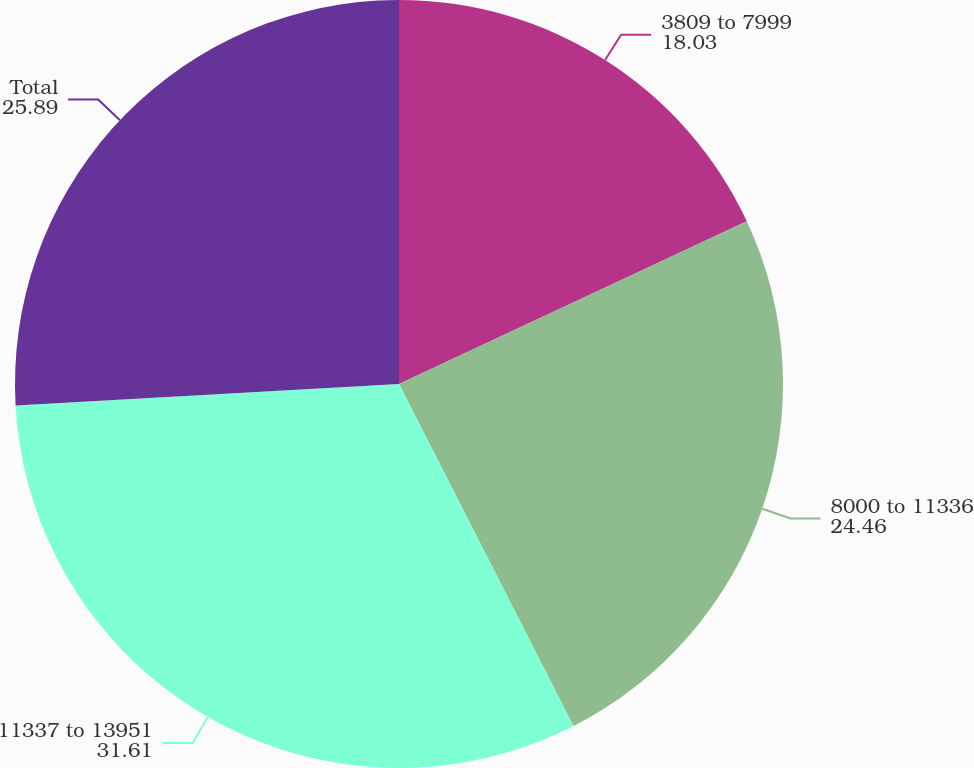Convert chart. <chart><loc_0><loc_0><loc_500><loc_500><pie_chart><fcel>3809 to 7999<fcel>8000 to 11336<fcel>11337 to 13951<fcel>Total<nl><fcel>18.03%<fcel>24.46%<fcel>31.61%<fcel>25.89%<nl></chart> 